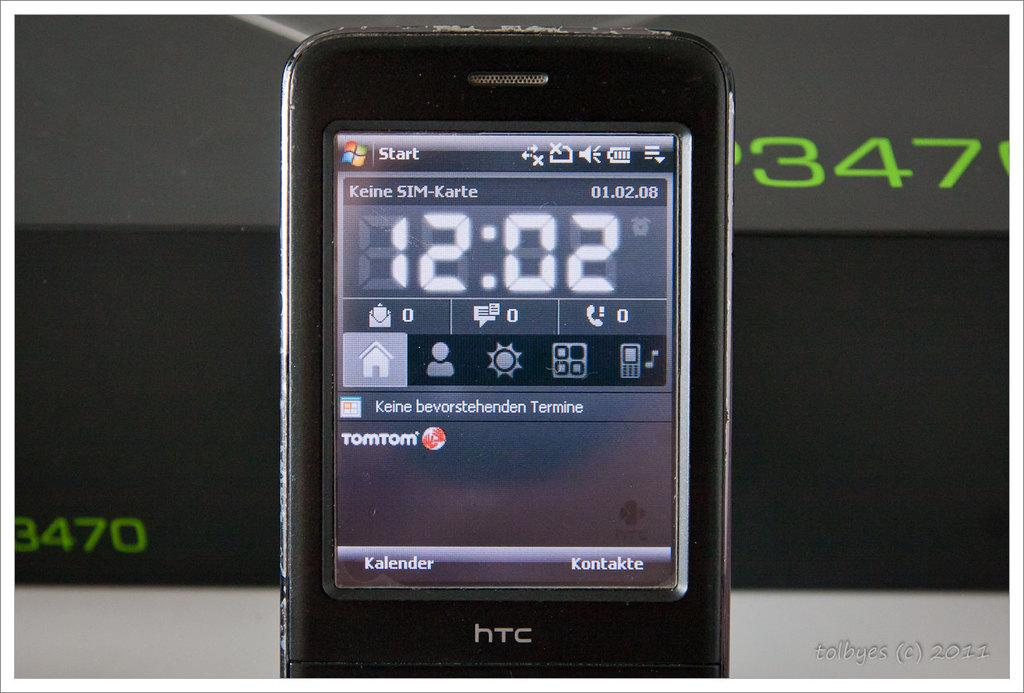<image>
Summarize the visual content of the image. an HTC cell phone displaying a time of 12:02 